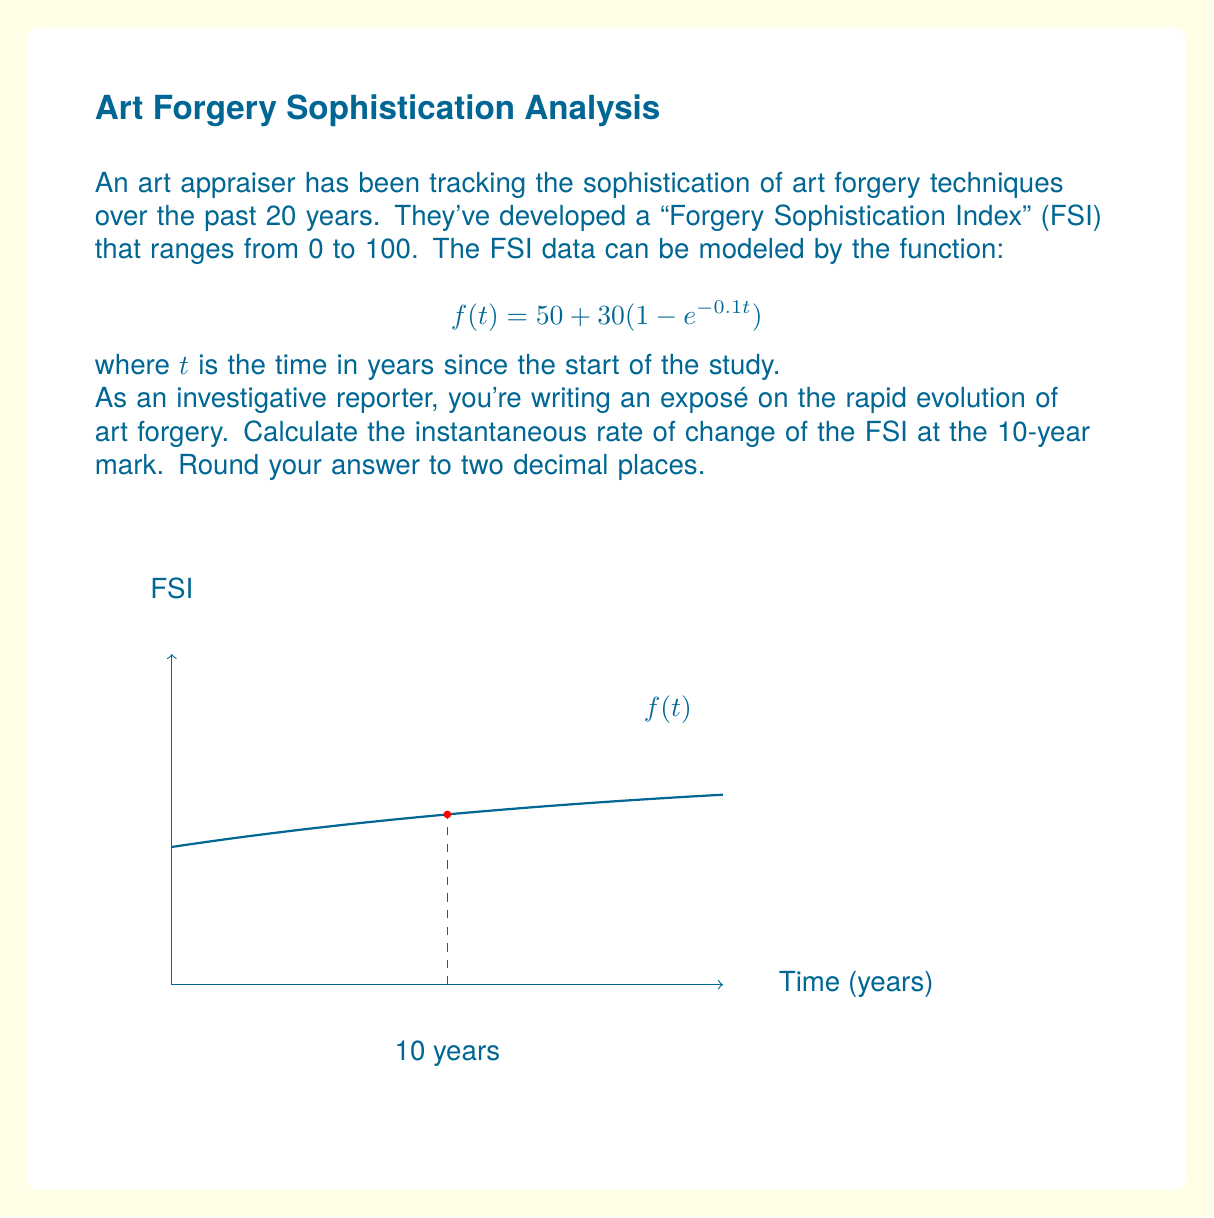Provide a solution to this math problem. To find the instantaneous rate of change at $t=10$, we need to calculate the derivative of $f(t)$ and then evaluate it at $t=10$. Let's break this down step-by-step:

1) First, let's find the derivative of $f(t)$:
   $$f(t) = 50 + 30(1 - e^{-0.1t})$$
   $$f(t) = 50 + 30 - 30e^{-0.1t}$$
   $$f'(t) = 0 + 0 + 30 \cdot 0.1e^{-0.1t}$$
   $$f'(t) = 3e^{-0.1t}$$

2) Now, we evaluate $f'(t)$ at $t=10$:
   $$f'(10) = 3e^{-0.1(10)}$$
   $$f'(10) = 3e^{-1}$$

3) Calculate this value:
   $$f'(10) = 3 \cdot 0.36787944117...$$
   $$f'(10) \approx 1.10363832351...$$

4) Rounding to two decimal places:
   $$f'(10) \approx 1.10$$

This value represents the instantaneous rate of change of the FSI at the 10-year mark, measured in FSI units per year.
Answer: 1.10 FSI units/year 